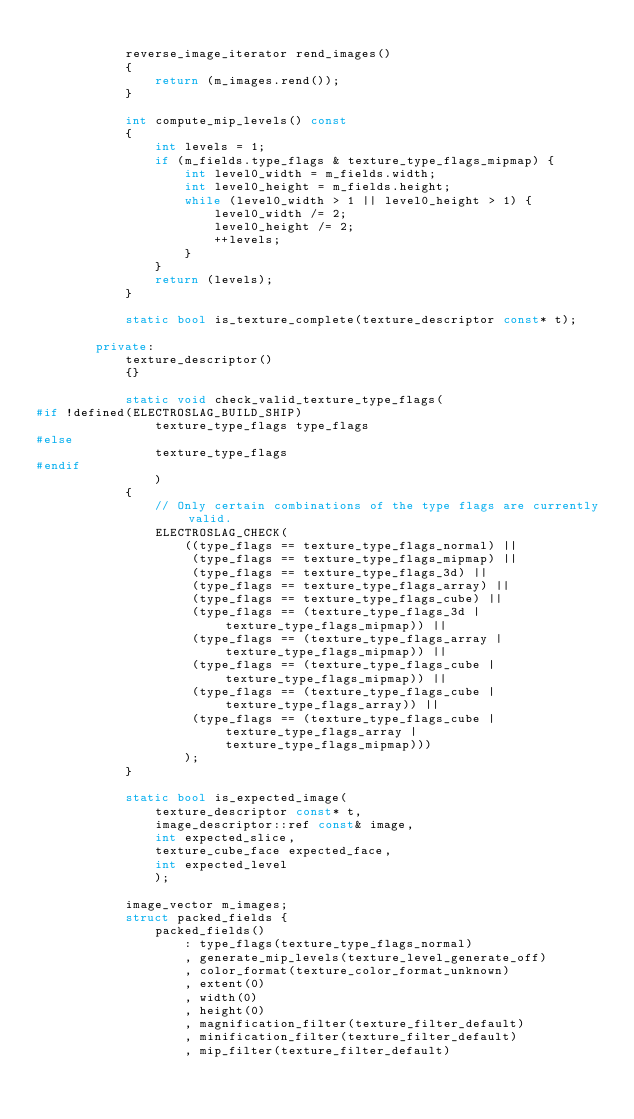<code> <loc_0><loc_0><loc_500><loc_500><_C++_>
            reverse_image_iterator rend_images()
            {
                return (m_images.rend());
            }

            int compute_mip_levels() const
            {
                int levels = 1;
                if (m_fields.type_flags & texture_type_flags_mipmap) {
                    int level0_width = m_fields.width;
                    int level0_height = m_fields.height;
                    while (level0_width > 1 || level0_height > 1) {
                        level0_width /= 2;
                        level0_height /= 2;
                        ++levels;
                    }
                }
                return (levels);
            }

            static bool is_texture_complete(texture_descriptor const* t);

        private:
            texture_descriptor()
            {}

            static void check_valid_texture_type_flags(
#if !defined(ELECTROSLAG_BUILD_SHIP)
                texture_type_flags type_flags
#else
                texture_type_flags
#endif
                )
            {
                // Only certain combinations of the type flags are currently valid.
                ELECTROSLAG_CHECK(
                    ((type_flags == texture_type_flags_normal) ||
                     (type_flags == texture_type_flags_mipmap) ||
                     (type_flags == texture_type_flags_3d) ||
                     (type_flags == texture_type_flags_array) ||
                     (type_flags == texture_type_flags_cube) ||
                     (type_flags == (texture_type_flags_3d | texture_type_flags_mipmap)) ||
                     (type_flags == (texture_type_flags_array | texture_type_flags_mipmap)) ||
                     (type_flags == (texture_type_flags_cube | texture_type_flags_mipmap)) ||
                     (type_flags == (texture_type_flags_cube | texture_type_flags_array)) ||
                     (type_flags == (texture_type_flags_cube | texture_type_flags_array | texture_type_flags_mipmap)))
                    );
            }

            static bool is_expected_image(
                texture_descriptor const* t,
                image_descriptor::ref const& image,
                int expected_slice,
                texture_cube_face expected_face,
                int expected_level
                );

            image_vector m_images;
            struct packed_fields {
                packed_fields()
                    : type_flags(texture_type_flags_normal)
                    , generate_mip_levels(texture_level_generate_off)
                    , color_format(texture_color_format_unknown)
                    , extent(0)
                    , width(0)
                    , height(0)
                    , magnification_filter(texture_filter_default)
                    , minification_filter(texture_filter_default)
                    , mip_filter(texture_filter_default)</code> 